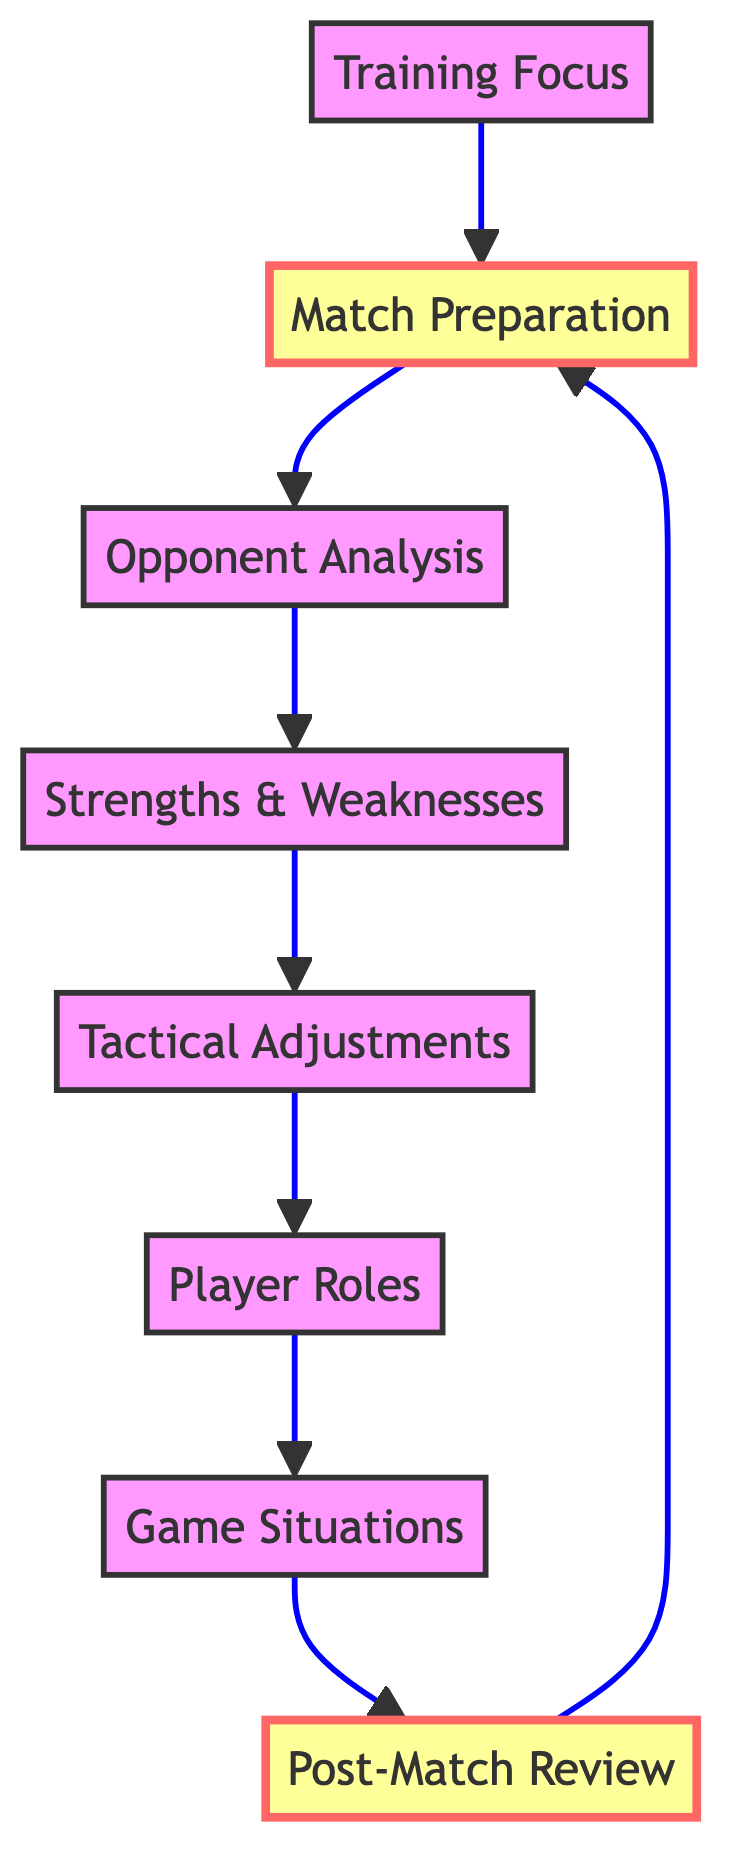What is the starting point for the game strategy? The diagram begins with the node labeled "Match Preparation," which indicates that this is the first step in the game strategy process.
Answer: Match Preparation How many nodes are present in the diagram? Counting the listed nodes, there are a total of eight nodes included in the diagram, each representing a step in the game strategy flow.
Answer: 8 Which node follows 'Tactical Adjustments'? The directed flow from 'Tactical Adjustments' points to the next node, which is labeled 'Player Roles.' This indicates the sequence of actions taken in the strategy.
Answer: Player Roles What is the final step before returning to 'Match Preparation'? After the 'Post-Match Review,' the flowchart returns to 'Match Preparation,' creating a loop in the game strategy process for continual improvement and adjustment.
Answer: Match Preparation Which node has the most incoming edges? The 'Match Preparation' node has two incoming edges: one from 'Post-Match Review' and one from 'Training Focus,' making it the node with the highest number of incoming connections.
Answer: Match Preparation What link connects 'Game Situations' and 'Post-Match Review'? The arrow from 'Game Situations' directs to 'Post-Match Review,' indicating that insights from game situations contribute to the review process after a match.
Answer: Post-Match Review What follows the 'Opponent Analysis' step? The flow continues from 'Opponent Analysis' to 'Strengths & Weaknesses,' marking the progression in the strategic analysis of the upcoming match.
Answer: Strengths & Weaknesses How does 'Training Focus' relate to 'Match Preparation'? The 'Training Focus' step directly connects to 'Match Preparation,' indicating that training efforts are aligned with the preparation for the match.
Answer: Match Preparation 